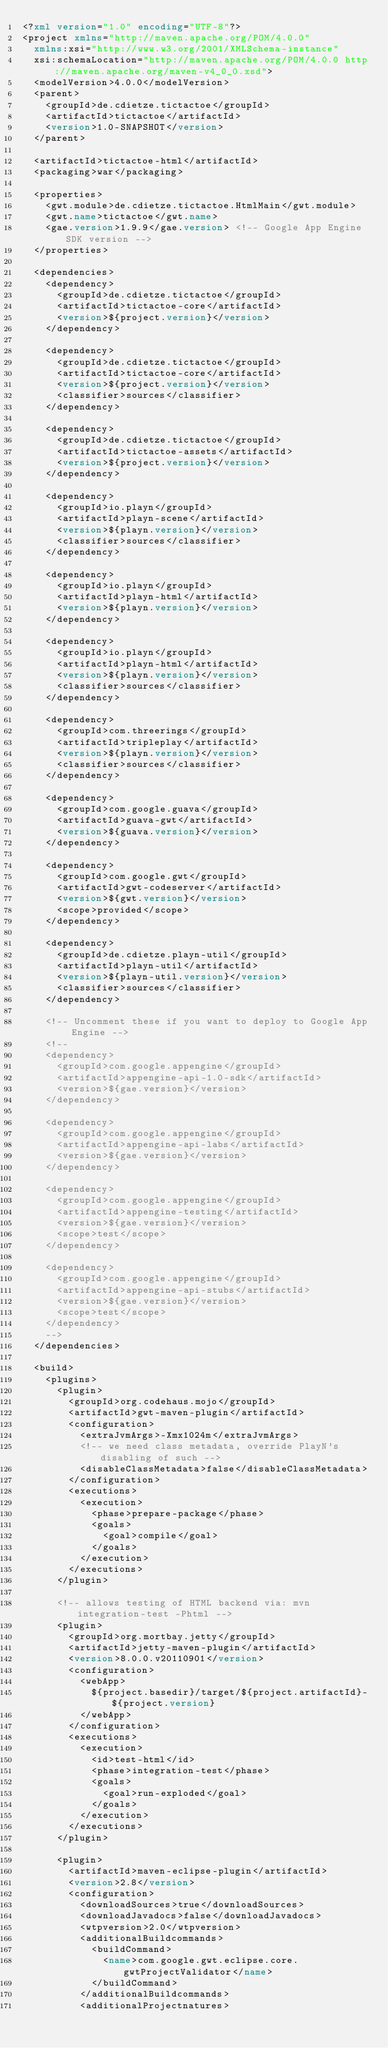Convert code to text. <code><loc_0><loc_0><loc_500><loc_500><_XML_><?xml version="1.0" encoding="UTF-8"?>
<project xmlns="http://maven.apache.org/POM/4.0.0"
  xmlns:xsi="http://www.w3.org/2001/XMLSchema-instance"
  xsi:schemaLocation="http://maven.apache.org/POM/4.0.0 http://maven.apache.org/maven-v4_0_0.xsd">
  <modelVersion>4.0.0</modelVersion>
  <parent>
    <groupId>de.cdietze.tictactoe</groupId>
    <artifactId>tictactoe</artifactId>
    <version>1.0-SNAPSHOT</version>
  </parent>

  <artifactId>tictactoe-html</artifactId>
  <packaging>war</packaging>

  <properties>
    <gwt.module>de.cdietze.tictactoe.HtmlMain</gwt.module>
    <gwt.name>tictactoe</gwt.name>
    <gae.version>1.9.9</gae.version> <!-- Google App Engine SDK version -->
  </properties>

  <dependencies>
    <dependency>
      <groupId>de.cdietze.tictactoe</groupId>
      <artifactId>tictactoe-core</artifactId>
      <version>${project.version}</version>
    </dependency>

    <dependency>
      <groupId>de.cdietze.tictactoe</groupId>
      <artifactId>tictactoe-core</artifactId>
      <version>${project.version}</version>
      <classifier>sources</classifier>
    </dependency>

    <dependency>
      <groupId>de.cdietze.tictactoe</groupId>
      <artifactId>tictactoe-assets</artifactId>
      <version>${project.version}</version>
    </dependency>

    <dependency>
      <groupId>io.playn</groupId>
      <artifactId>playn-scene</artifactId>
      <version>${playn.version}</version>
      <classifier>sources</classifier>
    </dependency>

    <dependency>
      <groupId>io.playn</groupId>
      <artifactId>playn-html</artifactId>
      <version>${playn.version}</version>
    </dependency>

    <dependency>
      <groupId>io.playn</groupId>
      <artifactId>playn-html</artifactId>
      <version>${playn.version}</version>
      <classifier>sources</classifier>
    </dependency>

    <dependency>
      <groupId>com.threerings</groupId>
      <artifactId>tripleplay</artifactId>
      <version>${playn.version}</version>
      <classifier>sources</classifier>
    </dependency>

    <dependency>
      <groupId>com.google.guava</groupId>
      <artifactId>guava-gwt</artifactId>
      <version>${guava.version}</version>
    </dependency>

    <dependency>
      <groupId>com.google.gwt</groupId>
      <artifactId>gwt-codeserver</artifactId>
      <version>${gwt.version}</version>
      <scope>provided</scope>
    </dependency>

    <dependency>
      <groupId>de.cdietze.playn-util</groupId>
      <artifactId>playn-util</artifactId>
      <version>${playn-util.version}</version>
      <classifier>sources</classifier>
    </dependency>

    <!-- Uncomment these if you want to deploy to Google App Engine -->
    <!--
    <dependency>
      <groupId>com.google.appengine</groupId>
      <artifactId>appengine-api-1.0-sdk</artifactId>
      <version>${gae.version}</version>
    </dependency>

    <dependency>
      <groupId>com.google.appengine</groupId>
      <artifactId>appengine-api-labs</artifactId>
      <version>${gae.version}</version>
    </dependency>

    <dependency>
      <groupId>com.google.appengine</groupId>
      <artifactId>appengine-testing</artifactId>
      <version>${gae.version}</version>
      <scope>test</scope>
    </dependency>

    <dependency>
      <groupId>com.google.appengine</groupId>
      <artifactId>appengine-api-stubs</artifactId>
      <version>${gae.version}</version>
      <scope>test</scope>
    </dependency>
    -->
  </dependencies>

  <build>
    <plugins>
      <plugin>
        <groupId>org.codehaus.mojo</groupId>
        <artifactId>gwt-maven-plugin</artifactId>
        <configuration>
          <extraJvmArgs>-Xmx1024m</extraJvmArgs>
          <!-- we need class metadata, override PlayN's disabling of such -->
          <disableClassMetadata>false</disableClassMetadata>
        </configuration>
        <executions>
          <execution>
            <phase>prepare-package</phase>
            <goals>
              <goal>compile</goal>
            </goals>
          </execution>
        </executions>
      </plugin>

      <!-- allows testing of HTML backend via: mvn integration-test -Phtml -->
      <plugin>
        <groupId>org.mortbay.jetty</groupId>
        <artifactId>jetty-maven-plugin</artifactId>
        <version>8.0.0.v20110901</version>
        <configuration>
          <webApp>
            ${project.basedir}/target/${project.artifactId}-${project.version}
          </webApp>
        </configuration>
        <executions>
          <execution>
            <id>test-html</id>
            <phase>integration-test</phase>
            <goals>
              <goal>run-exploded</goal>
            </goals>
          </execution>
        </executions>
      </plugin>

      <plugin>
        <artifactId>maven-eclipse-plugin</artifactId>
        <version>2.8</version>
        <configuration>
          <downloadSources>true</downloadSources>
          <downloadJavadocs>false</downloadJavadocs>
          <wtpversion>2.0</wtpversion>
          <additionalBuildcommands>
            <buildCommand>
              <name>com.google.gwt.eclipse.core.gwtProjectValidator</name>
            </buildCommand>
          </additionalBuildcommands>
          <additionalProjectnatures></code> 